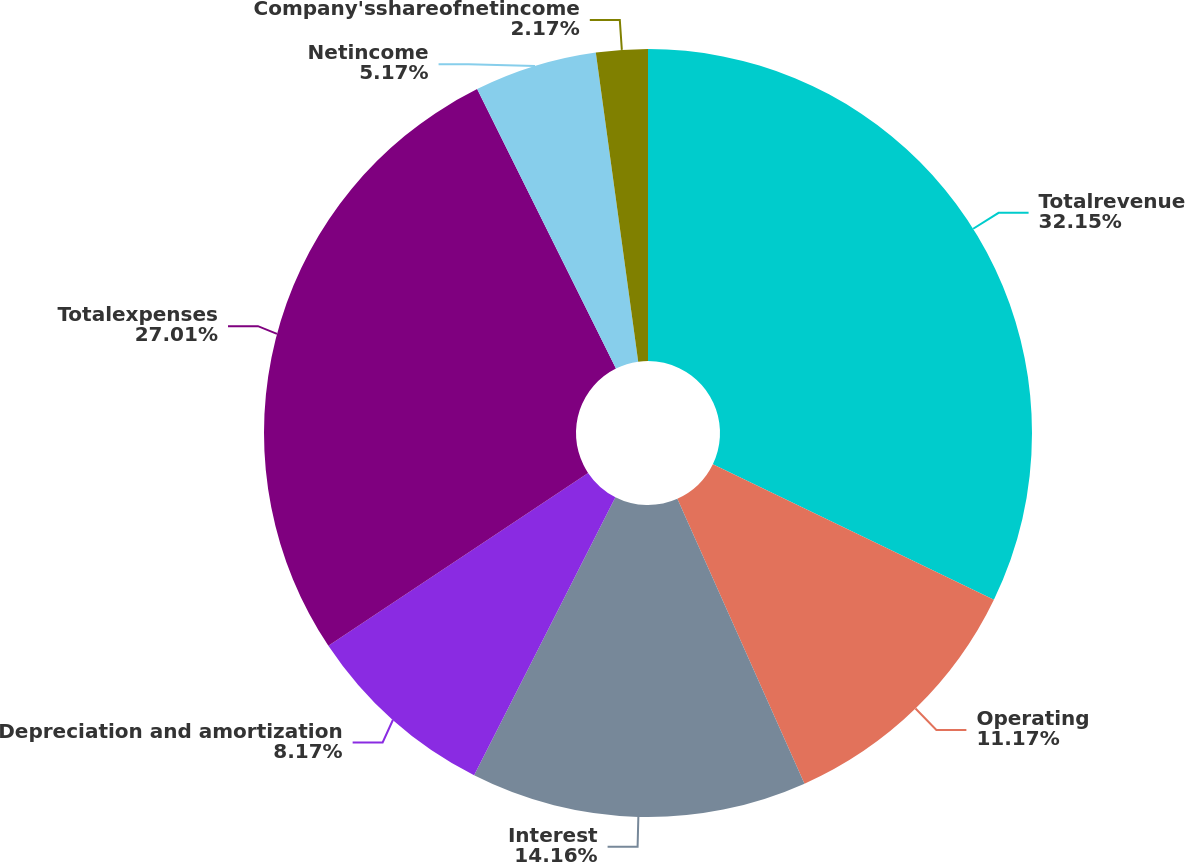<chart> <loc_0><loc_0><loc_500><loc_500><pie_chart><fcel>Totalrevenue<fcel>Operating<fcel>Interest<fcel>Depreciation and amortization<fcel>Totalexpenses<fcel>Netincome<fcel>Company'sshareofnetincome<nl><fcel>32.15%<fcel>11.17%<fcel>14.16%<fcel>8.17%<fcel>27.01%<fcel>5.17%<fcel>2.17%<nl></chart> 